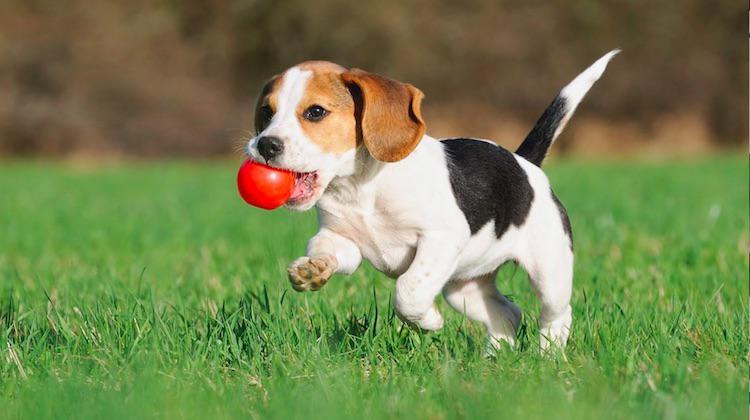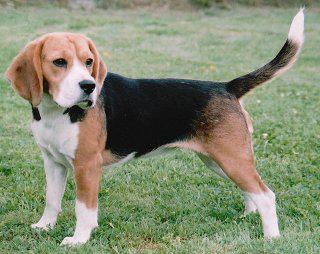The first image is the image on the left, the second image is the image on the right. Considering the images on both sides, is "There are more than one beagle in the image on the right" valid? Answer yes or no. No. 